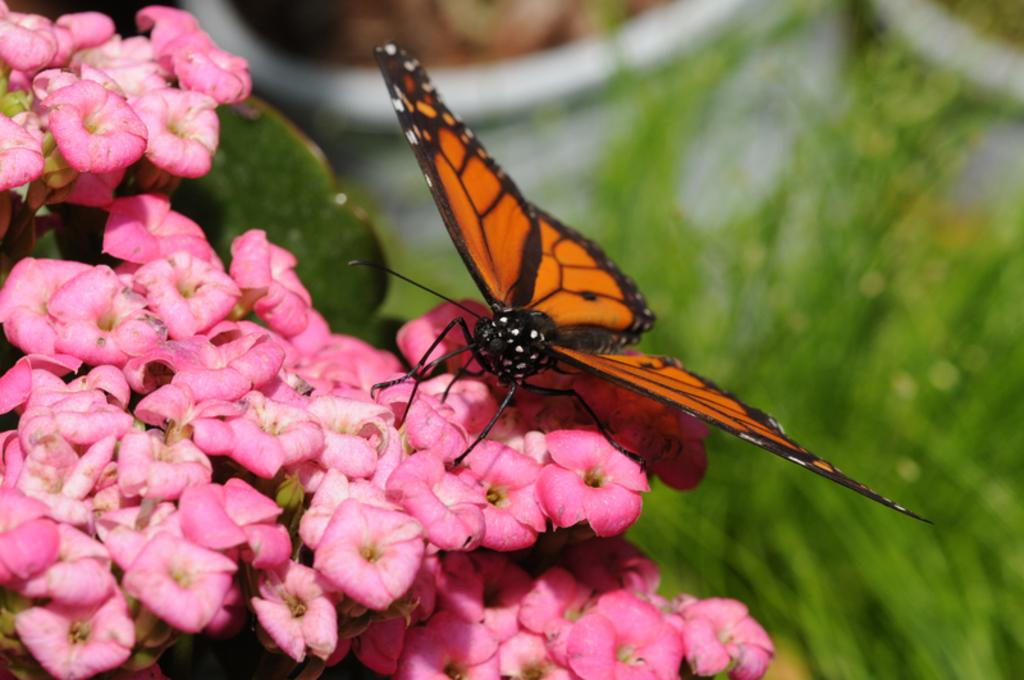What is the main subject of the image? There is a butterfly in the image. Where is the butterfly located? The butterfly is on the flowers in the image. How many flowers can be seen in the image? There are many flowers in the image. What other elements are present in the image besides flowers? There are leaves in the image. Can you describe the background of the image? The background has a blurred view. What colors are present in the image? The colors white, brown, and green are present in the image. What type of frame is around the butterfly in the image? There is no frame around the butterfly in the image; it is not a framed photograph. Is there a birthday celebration happening in the image? There is no indication of a birthday celebration in the image; it features a butterfly on flowers with leaves and a blurred background. 